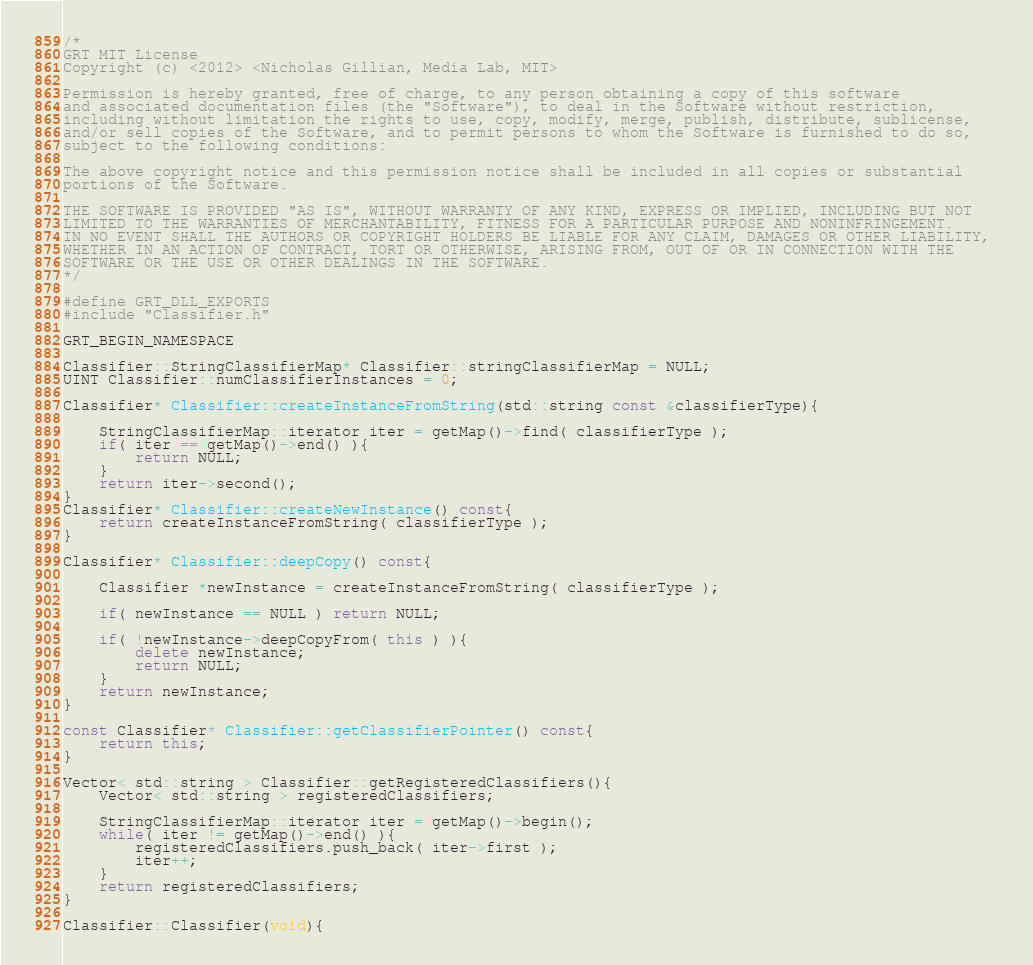Convert code to text. <code><loc_0><loc_0><loc_500><loc_500><_C++_>/*
GRT MIT License
Copyright (c) <2012> <Nicholas Gillian, Media Lab, MIT>

Permission is hereby granted, free of charge, to any person obtaining a copy of this software 
and associated documentation files (the "Software"), to deal in the Software without restriction, 
including without limitation the rights to use, copy, modify, merge, publish, distribute, sublicense, 
and/or sell copies of the Software, and to permit persons to whom the Software is furnished to do so, 
subject to the following conditions:

The above copyright notice and this permission notice shall be included in all copies or substantial 
portions of the Software.

THE SOFTWARE IS PROVIDED "AS IS", WITHOUT WARRANTY OF ANY KIND, EXPRESS OR IMPLIED, INCLUDING BUT NOT 
LIMITED TO THE WARRANTIES OF MERCHANTABILITY, FITNESS FOR A PARTICULAR PURPOSE AND NONINFRINGEMENT. 
IN NO EVENT SHALL THE AUTHORS OR COPYRIGHT HOLDERS BE LIABLE FOR ANY CLAIM, DAMAGES OR OTHER LIABILITY, 
WHETHER IN AN ACTION OF CONTRACT, TORT OR OTHERWISE, ARISING FROM, OUT OF OR IN CONNECTION WITH THE 
SOFTWARE OR THE USE OR OTHER DEALINGS IN THE SOFTWARE.
*/

#define GRT_DLL_EXPORTS
#include "Classifier.h"

GRT_BEGIN_NAMESPACE
    
Classifier::StringClassifierMap* Classifier::stringClassifierMap = NULL;
UINT Classifier::numClassifierInstances = 0;
    
Classifier* Classifier::createInstanceFromString(std::string const &classifierType){
    
    StringClassifierMap::iterator iter = getMap()->find( classifierType );
    if( iter == getMap()->end() ){
        return NULL;
    }
    return iter->second();
}
Classifier* Classifier::createNewInstance() const{
    return createInstanceFromString( classifierType );
}
    
Classifier* Classifier::deepCopy() const{
    
    Classifier *newInstance = createInstanceFromString( classifierType );
    
    if( newInstance == NULL ) return NULL;
    
    if( !newInstance->deepCopyFrom( this ) ){
        delete newInstance;
        return NULL;
    }
    return newInstance;
}
    
const Classifier* Classifier::getClassifierPointer() const{
    return this;
}

Vector< std::string > Classifier::getRegisteredClassifiers(){
	Vector< std::string > registeredClassifiers;
	
	StringClassifierMap::iterator iter = getMap()->begin();
	while( iter != getMap()->end() ){
		registeredClassifiers.push_back( iter->first );
		iter++;
	}
	return registeredClassifiers;
}
    
Classifier::Classifier(void){</code> 